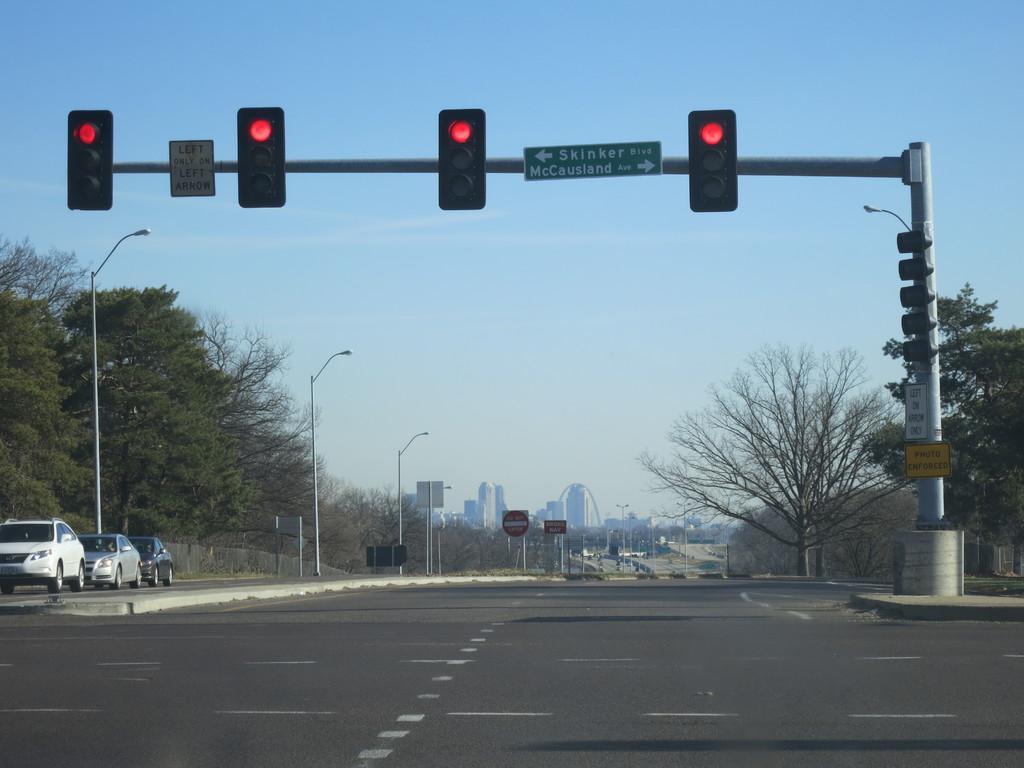How would you summarize this image in a sentence or two? In the image there is a road and beside the road there are traffic signals, all the signals are showing red light. On the left side there are three cars and beside the cars there are plenty trees around the road. In the background there are some buildings. 